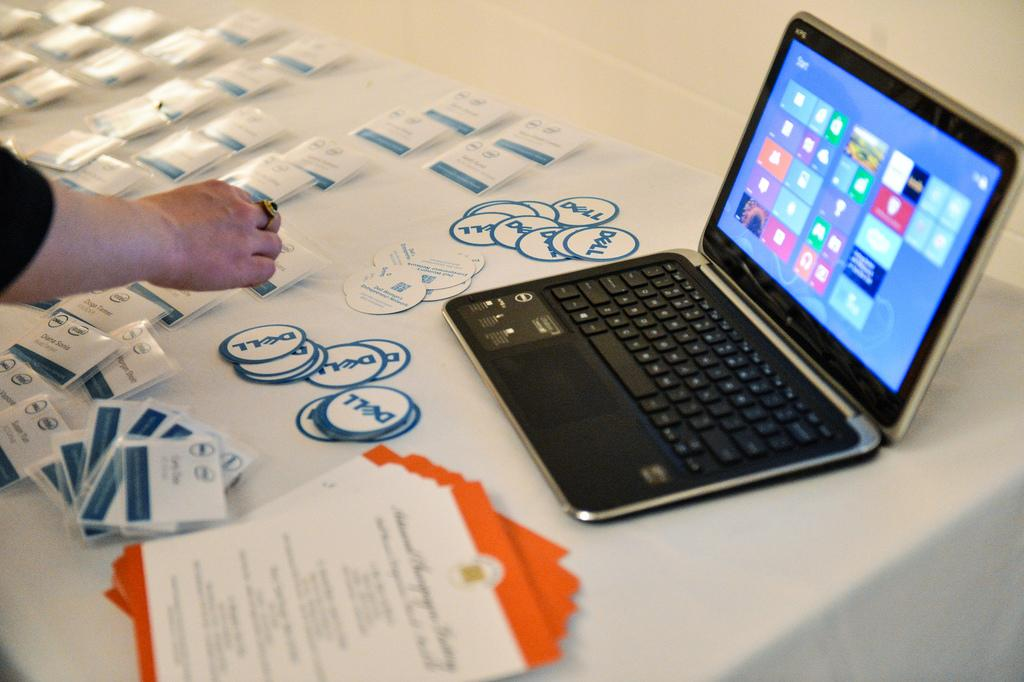<image>
Write a terse but informative summary of the picture. A Dell computer is on a table with many Dell logo stickers. 